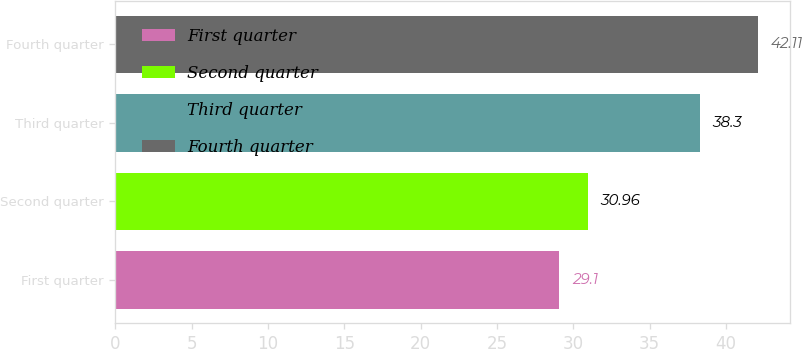Convert chart to OTSL. <chart><loc_0><loc_0><loc_500><loc_500><bar_chart><fcel>First quarter<fcel>Second quarter<fcel>Third quarter<fcel>Fourth quarter<nl><fcel>29.1<fcel>30.96<fcel>38.3<fcel>42.11<nl></chart> 